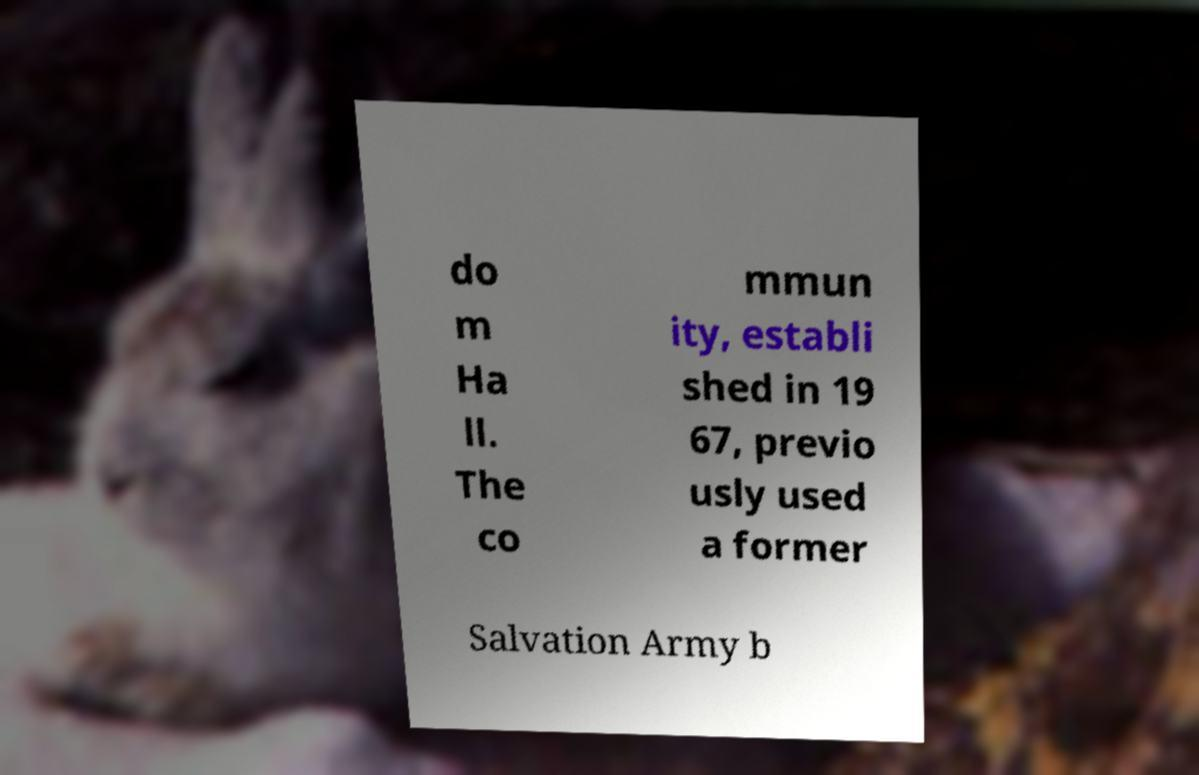What messages or text are displayed in this image? I need them in a readable, typed format. do m Ha ll. The co mmun ity, establi shed in 19 67, previo usly used a former Salvation Army b 